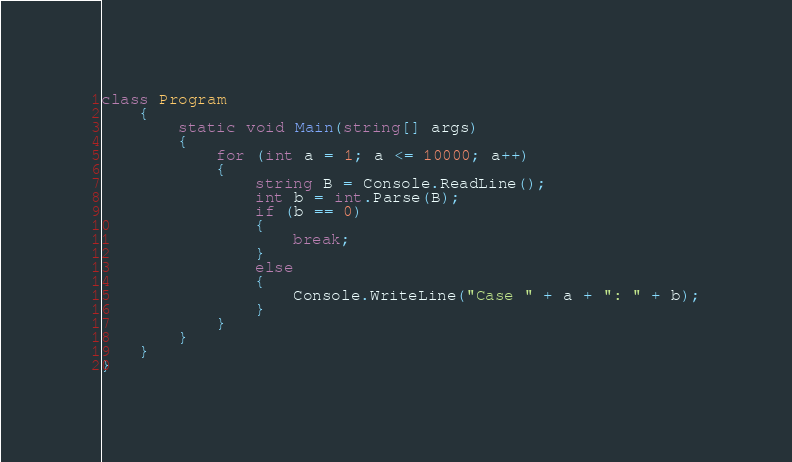<code> <loc_0><loc_0><loc_500><loc_500><_C#_>class Program
    {
        static void Main(string[] args)
        {
            for (int a = 1; a <= 10000; a++)
            {
                string B = Console.ReadLine();
                int b = int.Parse(B);
                if (b == 0)
                {
                    break;
                }
                else
                {
                    Console.WriteLine("Case " + a + ": " + b);
                }
            }
        }
    }
}</code> 